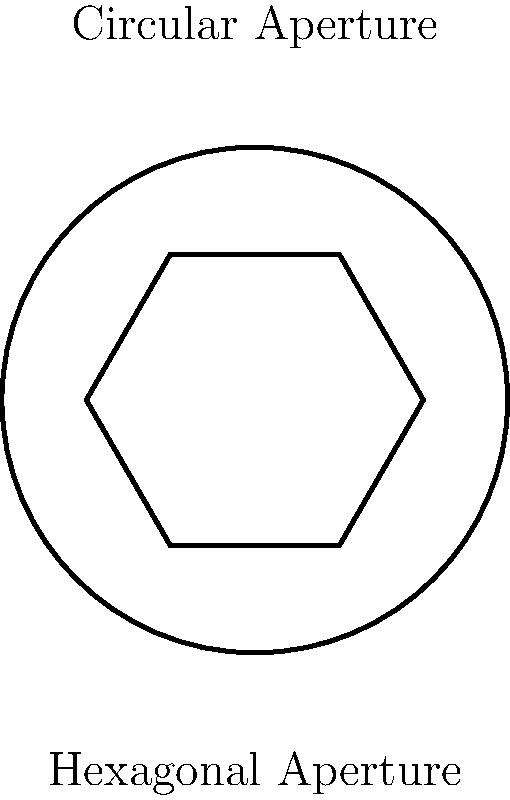A camera's aperture shape affects the appearance of out-of-focus points of light, known as bokeh. Compare a hexagonal aperture with a circular aperture, both having the same area. If the side length of the hexagon is $s$, what is the radius $r$ of the circular aperture in terms of $s$? Let's approach this step-by-step:

1) First, we need to find the area of a regular hexagon with side length $s$:
   Area of hexagon = $\frac{3\sqrt{3}}{2}s^2$

2) Now, let's set this equal to the area of a circle with radius $r$:
   $\frac{3\sqrt{3}}{2}s^2 = \pi r^2$

3) Solve for $r$:
   $r^2 = \frac{3\sqrt{3}}{2\pi}s^2$

4) Take the square root of both sides:
   $r = s\sqrt{\frac{3\sqrt{3}}{2\pi}}$

5) Simplify the fraction under the square root:
   $r = s\sqrt{\frac{\sqrt{3}}{2\sqrt{\pi}}}$

This gives us the radius of the circular aperture in terms of the side length of the hexagonal aperture.
Answer: $r = s\sqrt{\frac{\sqrt{3}}{2\sqrt{\pi}}}$ 